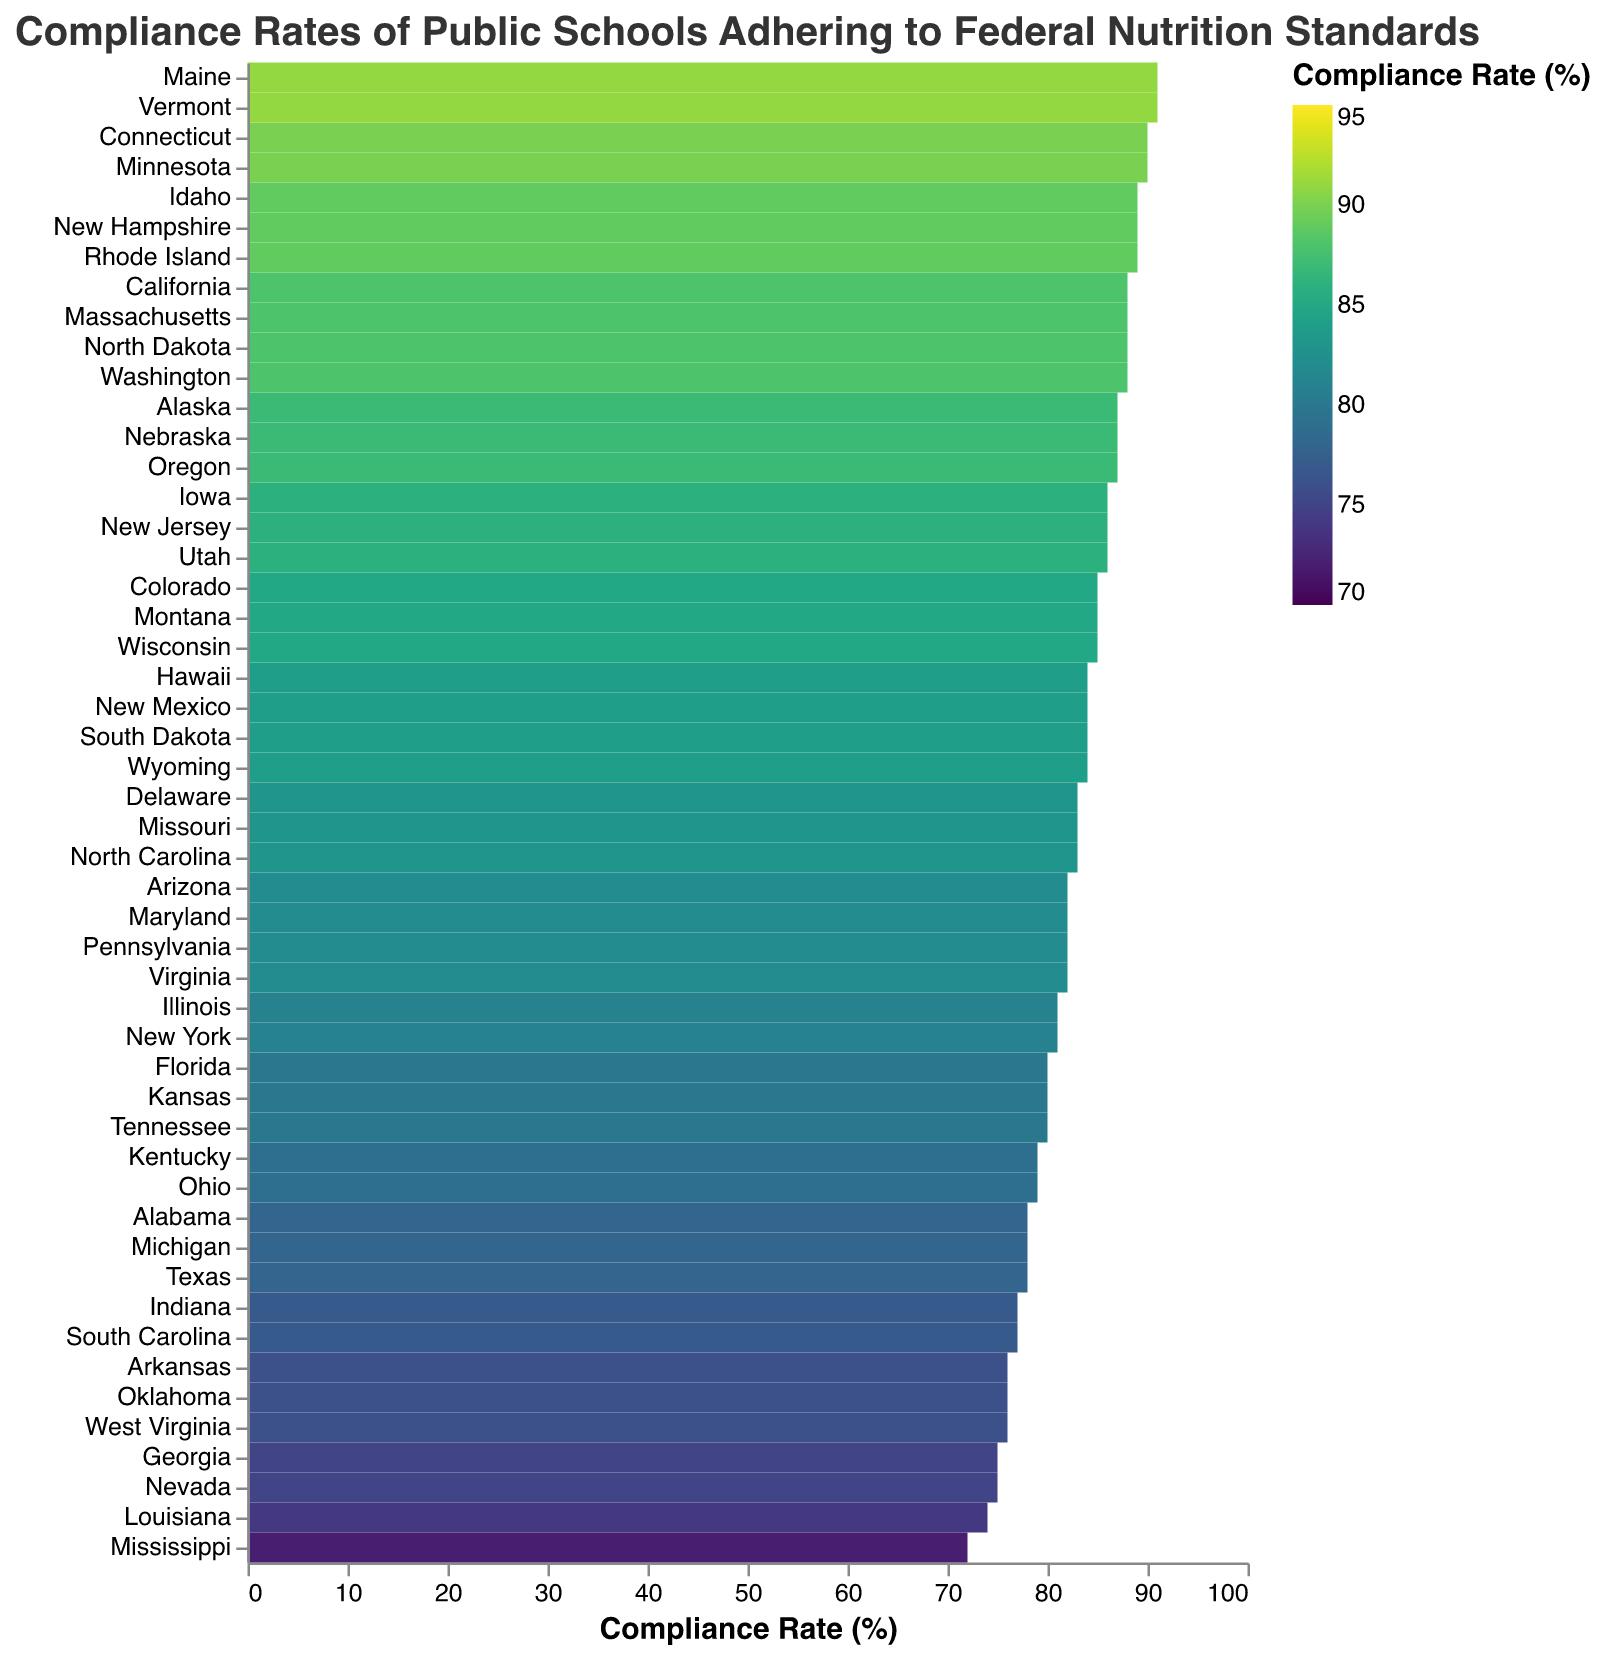What is the title of the heatmap? The title is displayed at the top of the figure, indicating what the data represents.
Answer: Compliance Rates of Public Schools Adhering to Federal Nutrition Standards Which state has the highest compliance rate? Look for the darkest color on the heatmap, which corresponds to the highest compliance rate.
Answer: Maine and Vermont How many states have compliance rates above 85%? Count the number of states whose color corresponds to a compliance rate above 85%.
Answer: 16 Which state has the lowest compliance rate and what is the value? Look for the lightest color on the heatmap, which corresponds to the lowest compliance rate.
Answer: Mississippi, 72% What is the compliance rate for California? Locate California on the heatmap and read off the color value that corresponds to its compliance rate.
Answer: 88% Compare the compliance rates of Texas and Nevada. Which one is higher? Find the color values for Texas and Nevada, and compare their compliance rates.
Answer: Texas is higher What is the average compliance rate of the top 5 states with the highest compliance rates? Identify the top 5 states with the highest compliance rates and compute the average.
Answer: (91 + 91 + 90 + 90 + 89) / 5 = 90.2 Which state has a compliance rate of 83%? Look for the state(s) that are colored to correspond with a compliance rate of 83%.
Answer: Delaware, Missouri, North Carolina What is the range of the compliance rates shown in the heatmap? Subtract the lowest compliance rate value from the highest compliance rate value.
Answer: 91% - 72% = 19% How do the compliance rates of Southern states (like Alabama, Georgia, and Mississippi) compare to the national average? Find the compliance rates for Southern states listed and compare them to the national average compliance rate, computed from all state values.
Answer: Typically lower than the national average 